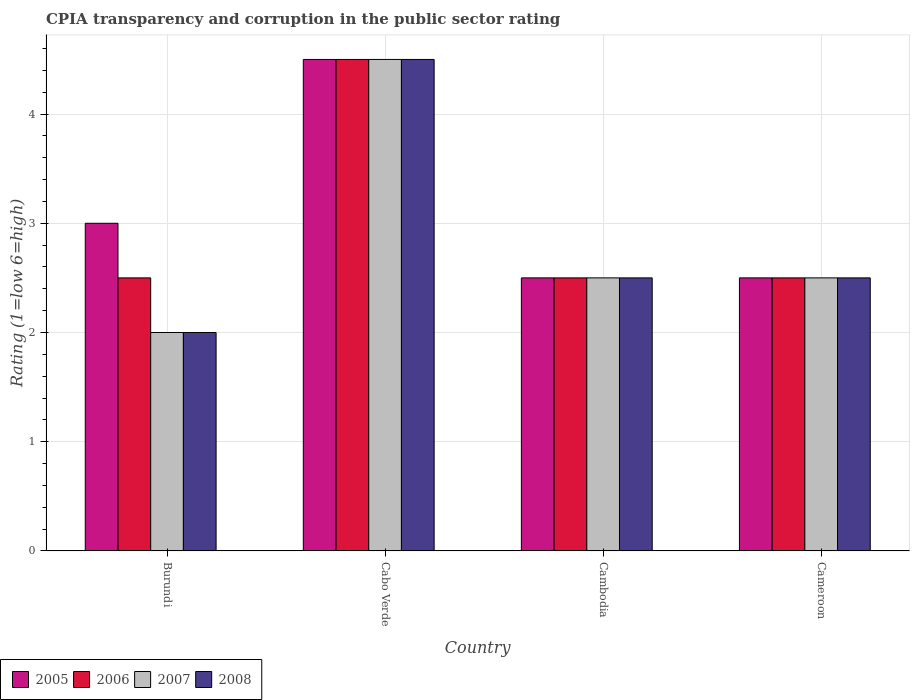How many different coloured bars are there?
Give a very brief answer. 4. How many groups of bars are there?
Give a very brief answer. 4. Are the number of bars per tick equal to the number of legend labels?
Provide a succinct answer. Yes. How many bars are there on the 2nd tick from the left?
Your answer should be compact. 4. How many bars are there on the 2nd tick from the right?
Offer a terse response. 4. What is the label of the 2nd group of bars from the left?
Make the answer very short. Cabo Verde. What is the CPIA rating in 2005 in Burundi?
Your answer should be very brief. 3. In which country was the CPIA rating in 2006 maximum?
Offer a terse response. Cabo Verde. In which country was the CPIA rating in 2007 minimum?
Your answer should be very brief. Burundi. What is the total CPIA rating in 2007 in the graph?
Provide a short and direct response. 11.5. What is the difference between the CPIA rating in 2008 in Cambodia and that in Cameroon?
Ensure brevity in your answer.  0. What is the difference between the CPIA rating of/in 2005 and CPIA rating of/in 2007 in Cambodia?
Give a very brief answer. 0. Is the CPIA rating in 2006 in Burundi less than that in Cabo Verde?
Make the answer very short. Yes. What is the difference between the highest and the second highest CPIA rating in 2008?
Provide a succinct answer. -2. In how many countries, is the CPIA rating in 2005 greater than the average CPIA rating in 2005 taken over all countries?
Your answer should be compact. 1. Is it the case that in every country, the sum of the CPIA rating in 2008 and CPIA rating in 2005 is greater than the sum of CPIA rating in 2006 and CPIA rating in 2007?
Offer a terse response. No. What does the 2nd bar from the left in Cambodia represents?
Make the answer very short. 2006. Is it the case that in every country, the sum of the CPIA rating in 2006 and CPIA rating in 2007 is greater than the CPIA rating in 2008?
Make the answer very short. Yes. Are the values on the major ticks of Y-axis written in scientific E-notation?
Your answer should be very brief. No. How many legend labels are there?
Your answer should be compact. 4. How are the legend labels stacked?
Offer a terse response. Horizontal. What is the title of the graph?
Your answer should be very brief. CPIA transparency and corruption in the public sector rating. What is the label or title of the X-axis?
Your answer should be very brief. Country. What is the Rating (1=low 6=high) of 2005 in Burundi?
Make the answer very short. 3. What is the Rating (1=low 6=high) of 2006 in Burundi?
Provide a short and direct response. 2.5. What is the Rating (1=low 6=high) of 2007 in Burundi?
Make the answer very short. 2. What is the Rating (1=low 6=high) of 2006 in Cabo Verde?
Make the answer very short. 4.5. What is the Rating (1=low 6=high) of 2007 in Cabo Verde?
Give a very brief answer. 4.5. What is the Rating (1=low 6=high) of 2008 in Cabo Verde?
Offer a terse response. 4.5. What is the Rating (1=low 6=high) in 2006 in Cambodia?
Your response must be concise. 2.5. What is the Rating (1=low 6=high) in 2008 in Cambodia?
Provide a succinct answer. 2.5. What is the Rating (1=low 6=high) of 2005 in Cameroon?
Keep it short and to the point. 2.5. What is the Rating (1=low 6=high) in 2007 in Cameroon?
Provide a short and direct response. 2.5. Across all countries, what is the maximum Rating (1=low 6=high) in 2005?
Provide a short and direct response. 4.5. Across all countries, what is the maximum Rating (1=low 6=high) in 2006?
Provide a short and direct response. 4.5. Across all countries, what is the maximum Rating (1=low 6=high) of 2007?
Make the answer very short. 4.5. Across all countries, what is the minimum Rating (1=low 6=high) in 2005?
Your answer should be very brief. 2.5. Across all countries, what is the minimum Rating (1=low 6=high) in 2008?
Give a very brief answer. 2. What is the total Rating (1=low 6=high) of 2007 in the graph?
Make the answer very short. 11.5. What is the difference between the Rating (1=low 6=high) of 2007 in Burundi and that in Cabo Verde?
Make the answer very short. -2.5. What is the difference between the Rating (1=low 6=high) in 2008 in Burundi and that in Cabo Verde?
Keep it short and to the point. -2.5. What is the difference between the Rating (1=low 6=high) of 2005 in Burundi and that in Cambodia?
Make the answer very short. 0.5. What is the difference between the Rating (1=low 6=high) of 2006 in Burundi and that in Cambodia?
Make the answer very short. 0. What is the difference between the Rating (1=low 6=high) of 2005 in Burundi and that in Cameroon?
Provide a succinct answer. 0.5. What is the difference between the Rating (1=low 6=high) of 2005 in Cabo Verde and that in Cambodia?
Provide a short and direct response. 2. What is the difference between the Rating (1=low 6=high) of 2006 in Cabo Verde and that in Cameroon?
Ensure brevity in your answer.  2. What is the difference between the Rating (1=low 6=high) in 2007 in Cambodia and that in Cameroon?
Your answer should be compact. 0. What is the difference between the Rating (1=low 6=high) in 2008 in Cambodia and that in Cameroon?
Provide a succinct answer. 0. What is the difference between the Rating (1=low 6=high) of 2006 in Burundi and the Rating (1=low 6=high) of 2007 in Cabo Verde?
Provide a succinct answer. -2. What is the difference between the Rating (1=low 6=high) in 2006 in Burundi and the Rating (1=low 6=high) in 2008 in Cabo Verde?
Provide a short and direct response. -2. What is the difference between the Rating (1=low 6=high) in 2007 in Burundi and the Rating (1=low 6=high) in 2008 in Cabo Verde?
Provide a short and direct response. -2.5. What is the difference between the Rating (1=low 6=high) in 2005 in Burundi and the Rating (1=low 6=high) in 2008 in Cambodia?
Provide a short and direct response. 0.5. What is the difference between the Rating (1=low 6=high) of 2006 in Burundi and the Rating (1=low 6=high) of 2007 in Cambodia?
Provide a succinct answer. 0. What is the difference between the Rating (1=low 6=high) in 2006 in Burundi and the Rating (1=low 6=high) in 2008 in Cambodia?
Offer a very short reply. 0. What is the difference between the Rating (1=low 6=high) of 2007 in Burundi and the Rating (1=low 6=high) of 2008 in Cambodia?
Provide a succinct answer. -0.5. What is the difference between the Rating (1=low 6=high) of 2005 in Burundi and the Rating (1=low 6=high) of 2007 in Cameroon?
Make the answer very short. 0.5. What is the difference between the Rating (1=low 6=high) in 2005 in Burundi and the Rating (1=low 6=high) in 2008 in Cameroon?
Your response must be concise. 0.5. What is the difference between the Rating (1=low 6=high) in 2006 in Burundi and the Rating (1=low 6=high) in 2007 in Cameroon?
Offer a terse response. 0. What is the difference between the Rating (1=low 6=high) in 2006 in Burundi and the Rating (1=low 6=high) in 2008 in Cameroon?
Offer a very short reply. 0. What is the difference between the Rating (1=low 6=high) of 2005 in Cabo Verde and the Rating (1=low 6=high) of 2008 in Cambodia?
Your response must be concise. 2. What is the difference between the Rating (1=low 6=high) in 2006 in Cabo Verde and the Rating (1=low 6=high) in 2008 in Cambodia?
Offer a terse response. 2. What is the difference between the Rating (1=low 6=high) in 2007 in Cabo Verde and the Rating (1=low 6=high) in 2008 in Cambodia?
Make the answer very short. 2. What is the difference between the Rating (1=low 6=high) of 2006 in Cabo Verde and the Rating (1=low 6=high) of 2008 in Cameroon?
Offer a very short reply. 2. What is the difference between the Rating (1=low 6=high) of 2005 in Cambodia and the Rating (1=low 6=high) of 2006 in Cameroon?
Offer a very short reply. 0. What is the difference between the Rating (1=low 6=high) of 2005 in Cambodia and the Rating (1=low 6=high) of 2008 in Cameroon?
Your answer should be compact. 0. What is the difference between the Rating (1=low 6=high) in 2006 in Cambodia and the Rating (1=low 6=high) in 2008 in Cameroon?
Keep it short and to the point. 0. What is the difference between the Rating (1=low 6=high) in 2007 in Cambodia and the Rating (1=low 6=high) in 2008 in Cameroon?
Offer a very short reply. 0. What is the average Rating (1=low 6=high) of 2005 per country?
Your answer should be very brief. 3.12. What is the average Rating (1=low 6=high) in 2007 per country?
Provide a short and direct response. 2.88. What is the average Rating (1=low 6=high) in 2008 per country?
Your answer should be compact. 2.88. What is the difference between the Rating (1=low 6=high) of 2005 and Rating (1=low 6=high) of 2007 in Burundi?
Your response must be concise. 1. What is the difference between the Rating (1=low 6=high) of 2006 and Rating (1=low 6=high) of 2007 in Burundi?
Your response must be concise. 0.5. What is the difference between the Rating (1=low 6=high) of 2006 and Rating (1=low 6=high) of 2008 in Burundi?
Ensure brevity in your answer.  0.5. What is the difference between the Rating (1=low 6=high) in 2005 and Rating (1=low 6=high) in 2007 in Cabo Verde?
Offer a very short reply. 0. What is the difference between the Rating (1=low 6=high) of 2005 and Rating (1=low 6=high) of 2008 in Cabo Verde?
Provide a short and direct response. 0. What is the difference between the Rating (1=low 6=high) in 2006 and Rating (1=low 6=high) in 2007 in Cabo Verde?
Make the answer very short. 0. What is the difference between the Rating (1=low 6=high) of 2005 and Rating (1=low 6=high) of 2006 in Cambodia?
Your response must be concise. 0. What is the difference between the Rating (1=low 6=high) of 2005 and Rating (1=low 6=high) of 2008 in Cambodia?
Your answer should be very brief. 0. What is the difference between the Rating (1=low 6=high) of 2006 and Rating (1=low 6=high) of 2008 in Cambodia?
Make the answer very short. 0. What is the difference between the Rating (1=low 6=high) in 2007 and Rating (1=low 6=high) in 2008 in Cambodia?
Your response must be concise. 0. What is the difference between the Rating (1=low 6=high) of 2005 and Rating (1=low 6=high) of 2007 in Cameroon?
Your answer should be very brief. 0. What is the difference between the Rating (1=low 6=high) in 2005 and Rating (1=low 6=high) in 2008 in Cameroon?
Your response must be concise. 0. What is the ratio of the Rating (1=low 6=high) in 2005 in Burundi to that in Cabo Verde?
Provide a short and direct response. 0.67. What is the ratio of the Rating (1=low 6=high) in 2006 in Burundi to that in Cabo Verde?
Provide a short and direct response. 0.56. What is the ratio of the Rating (1=low 6=high) of 2007 in Burundi to that in Cabo Verde?
Give a very brief answer. 0.44. What is the ratio of the Rating (1=low 6=high) in 2008 in Burundi to that in Cabo Verde?
Offer a terse response. 0.44. What is the ratio of the Rating (1=low 6=high) in 2005 in Burundi to that in Cambodia?
Ensure brevity in your answer.  1.2. What is the ratio of the Rating (1=low 6=high) in 2008 in Burundi to that in Cambodia?
Keep it short and to the point. 0.8. What is the ratio of the Rating (1=low 6=high) of 2005 in Burundi to that in Cameroon?
Provide a short and direct response. 1.2. What is the ratio of the Rating (1=low 6=high) of 2007 in Burundi to that in Cameroon?
Offer a terse response. 0.8. What is the ratio of the Rating (1=low 6=high) in 2008 in Burundi to that in Cameroon?
Make the answer very short. 0.8. What is the ratio of the Rating (1=low 6=high) in 2005 in Cabo Verde to that in Cambodia?
Provide a short and direct response. 1.8. What is the ratio of the Rating (1=low 6=high) of 2006 in Cabo Verde to that in Cambodia?
Your answer should be compact. 1.8. What is the ratio of the Rating (1=low 6=high) of 2007 in Cabo Verde to that in Cambodia?
Provide a short and direct response. 1.8. What is the ratio of the Rating (1=low 6=high) in 2005 in Cabo Verde to that in Cameroon?
Offer a terse response. 1.8. What is the ratio of the Rating (1=low 6=high) of 2006 in Cabo Verde to that in Cameroon?
Your answer should be very brief. 1.8. What is the ratio of the Rating (1=low 6=high) in 2006 in Cambodia to that in Cameroon?
Give a very brief answer. 1. What is the ratio of the Rating (1=low 6=high) in 2007 in Cambodia to that in Cameroon?
Offer a terse response. 1. What is the difference between the highest and the second highest Rating (1=low 6=high) of 2005?
Your response must be concise. 1.5. What is the difference between the highest and the second highest Rating (1=low 6=high) in 2007?
Provide a short and direct response. 2. What is the difference between the highest and the lowest Rating (1=low 6=high) of 2007?
Keep it short and to the point. 2.5. 